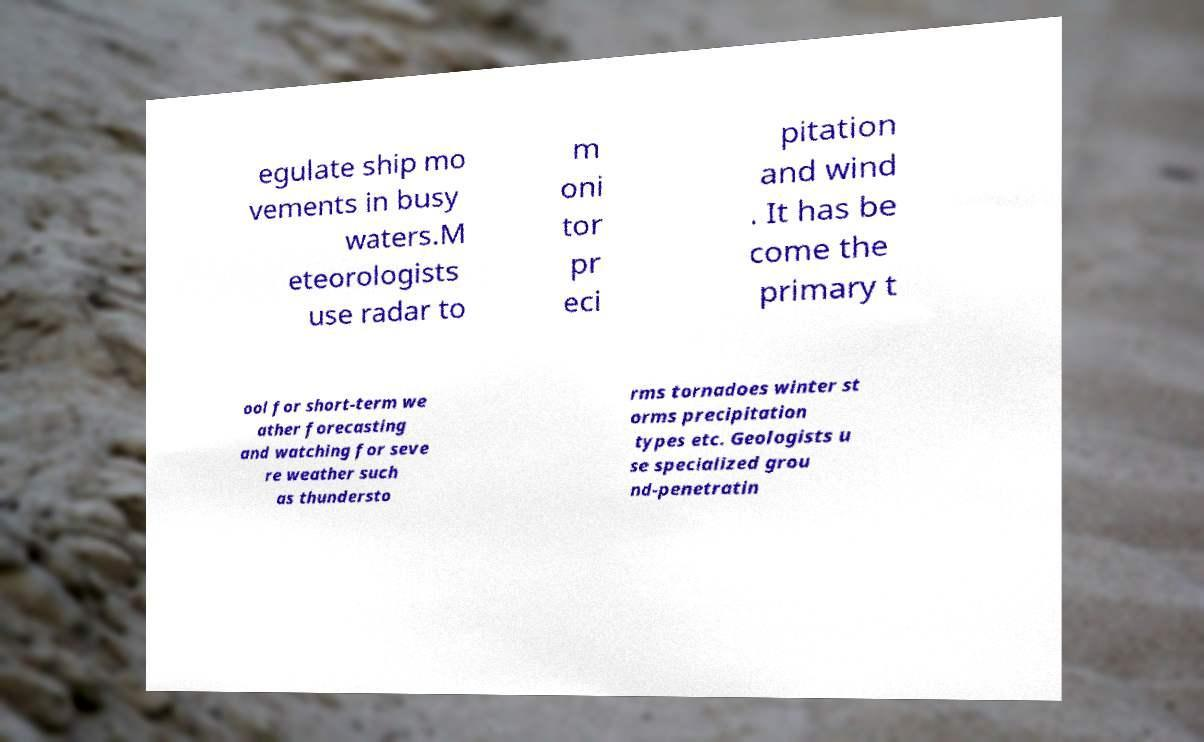There's text embedded in this image that I need extracted. Can you transcribe it verbatim? egulate ship mo vements in busy waters.M eteorologists use radar to m oni tor pr eci pitation and wind . It has be come the primary t ool for short-term we ather forecasting and watching for seve re weather such as thundersto rms tornadoes winter st orms precipitation types etc. Geologists u se specialized grou nd-penetratin 